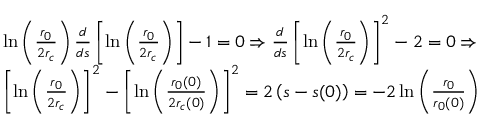Convert formula to latex. <formula><loc_0><loc_0><loc_500><loc_500>\begin{array} { r l } & { \ln \left ( \frac { r _ { 0 } } { 2 r _ { c } } \right ) \frac { d } { d s } \left [ \ln \left ( \frac { r _ { 0 } } { 2 r _ { c } } \right ) \right ] - 1 = 0 \Rightarrow \frac { d } { d s } \left [ \ln \left ( \frac { r _ { 0 } } { 2 r _ { c } } \right ) \right ] ^ { 2 } - 2 = 0 \Rightarrow } \\ & { \left [ \ln \left ( \frac { r _ { 0 } } { 2 r _ { c } } \right ) \right ] ^ { 2 } - \left [ \ln \left ( \frac { r _ { 0 } ( 0 ) } { 2 r _ { c } ( 0 ) } \right ) \right ] ^ { 2 } = 2 \left ( s - s ( 0 ) \right ) = - 2 \ln \left ( \frac { r _ { 0 } } { r _ { 0 } ( 0 ) } \right ) } \end{array}</formula> 